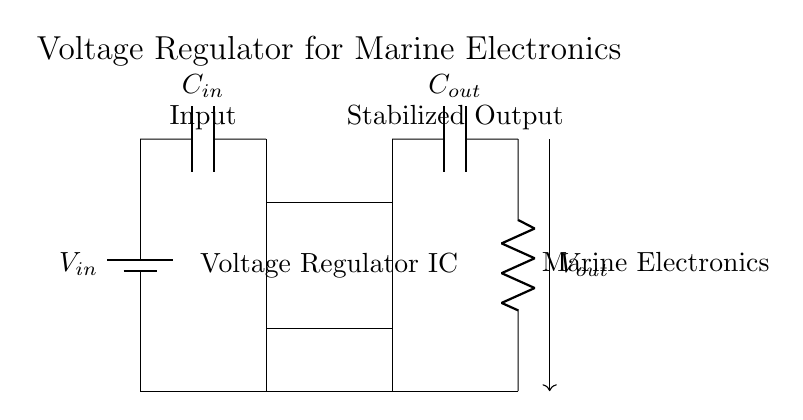What is the function of the voltage regulator IC? The voltage regulator IC stabilizes the output voltage for consistent power delivery to connected electronics.
Answer: Stabilization What type of capacitor is connected at the input? The input capacitor is typically a filter capacitor that smooths input voltage fluctuations before reaching the regulator.
Answer: C in What is the load connected to the output of the voltage regulator? The load connected to the output is marine electronics, which rely on stable power for operation.
Answer: Marine Electronics What would C out do in this circuit? The output capacitor filters and stabilizes the output voltage, minimizing ripples in the power supplied to the load.
Answer: Filtering What connections exist at the ground point? The ground point connects multiple components, providing a common return path for current and ensuring proper operation of the circuit.
Answer: Common ground Why is it important to stabilize the output voltage for marine electronics? Stabilizing the output voltage prevents fluctuations that could damage sensitive marine instruments or affect their performance stability.
Answer: Prevent damage How does the input voltage affect the output voltage in this circuit? The input voltage, when regulated by the IC, ensures that the output voltage remains consistent regardless of variations in the input supply.
Answer: Regulation 